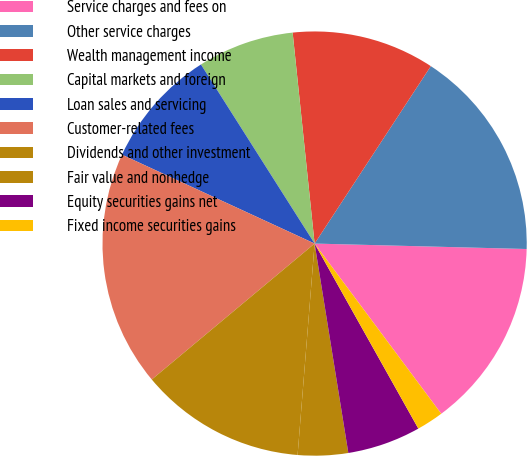Convert chart to OTSL. <chart><loc_0><loc_0><loc_500><loc_500><pie_chart><fcel>Service charges and fees on<fcel>Other service charges<fcel>Wealth management income<fcel>Capital markets and foreign<fcel>Loan sales and servicing<fcel>Customer-related fees<fcel>Dividends and other investment<fcel>Fair value and nonhedge<fcel>Equity securities gains net<fcel>Fixed income securities gains<nl><fcel>14.41%<fcel>16.18%<fcel>10.88%<fcel>7.35%<fcel>9.12%<fcel>17.95%<fcel>12.65%<fcel>3.82%<fcel>5.59%<fcel>2.05%<nl></chart> 